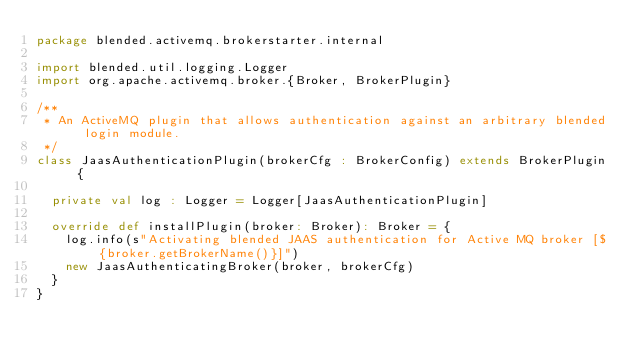Convert code to text. <code><loc_0><loc_0><loc_500><loc_500><_Scala_>package blended.activemq.brokerstarter.internal

import blended.util.logging.Logger
import org.apache.activemq.broker.{Broker, BrokerPlugin}

/**
 * An ActiveMQ plugin that allows authentication against an arbitrary blended login module.
 */
class JaasAuthenticationPlugin(brokerCfg : BrokerConfig) extends BrokerPlugin {

  private val log : Logger = Logger[JaasAuthenticationPlugin]

  override def installPlugin(broker: Broker): Broker = {
    log.info(s"Activating blended JAAS authentication for Active MQ broker [${broker.getBrokerName()}]")
    new JaasAuthenticatingBroker(broker, brokerCfg)
  }
}
</code> 